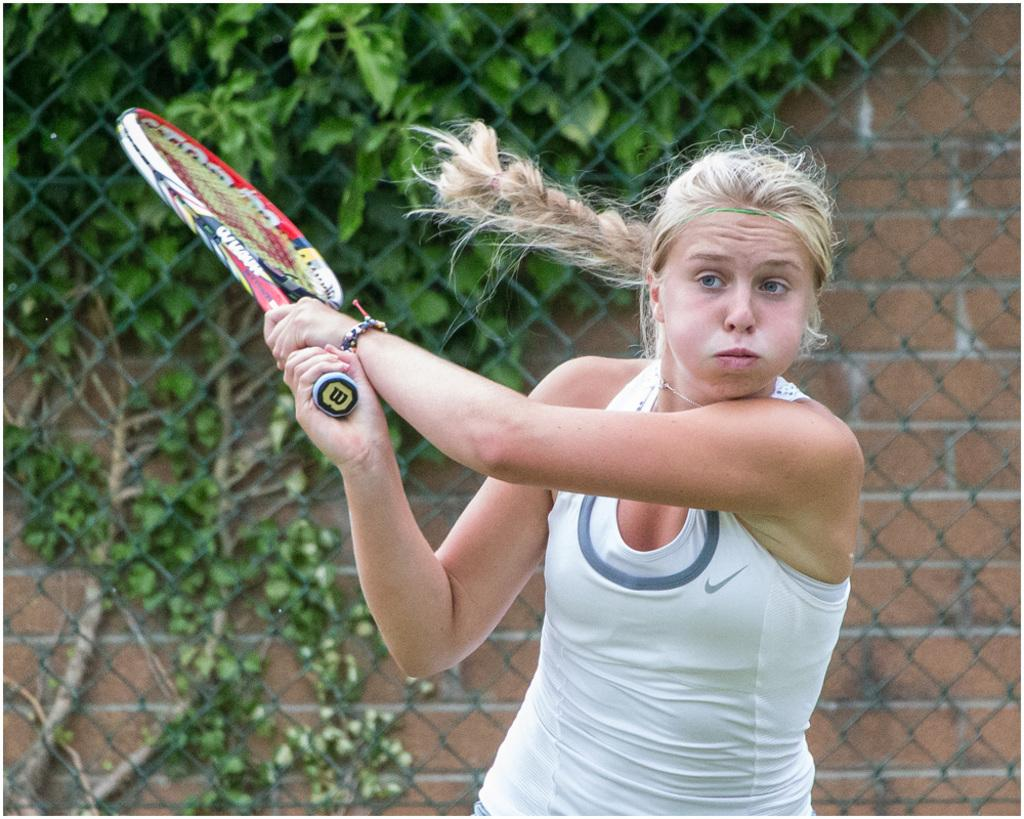Who is present in the image? There is a woman in the image. What is the woman holding in the image? The woman is holding a tennis racket. What can be seen in the background of the image? There is mesh fencing and a brick wall in the background of the image. What is growing on the brick wall? A creeper is growing on the brick wall. What is the price of the spoon in the image? There is no spoon present in the image, so it is not possible to determine its price. 